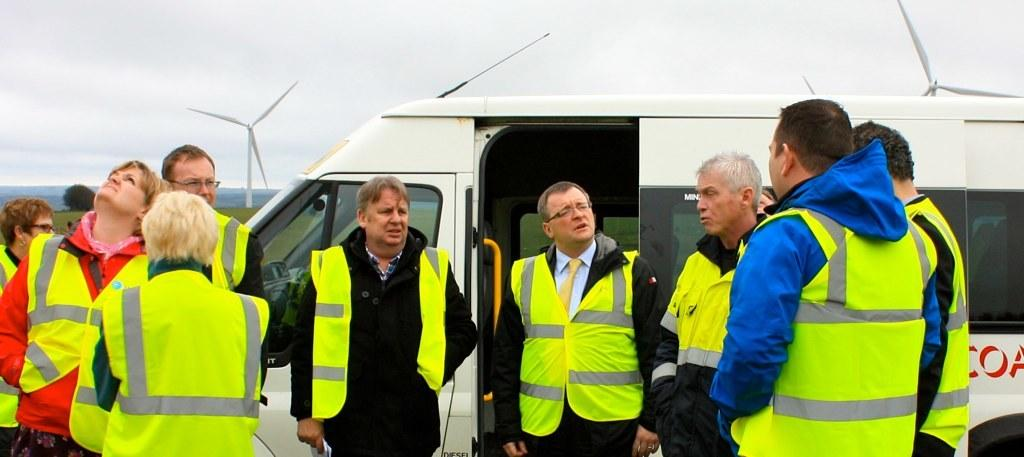What are the persons in the image wearing? The persons in the image are wearing jackets. What are the persons doing in the image? The persons are standing. What can be seen in the background of the image? There is a vehicle in the background of the image. What type of machinery is visible in the image? There are turbines visible in the image. What is the condition of the sky in the image? The sky is cloudy in the image. What type of riddle can be solved by the persons in the image? There is no riddle present in the image, and the persons are not engaged in solving any riddles. What key is used to unlock the turbines in the image? There are no keys visible in the image, and the turbines do not require a key to operate. 